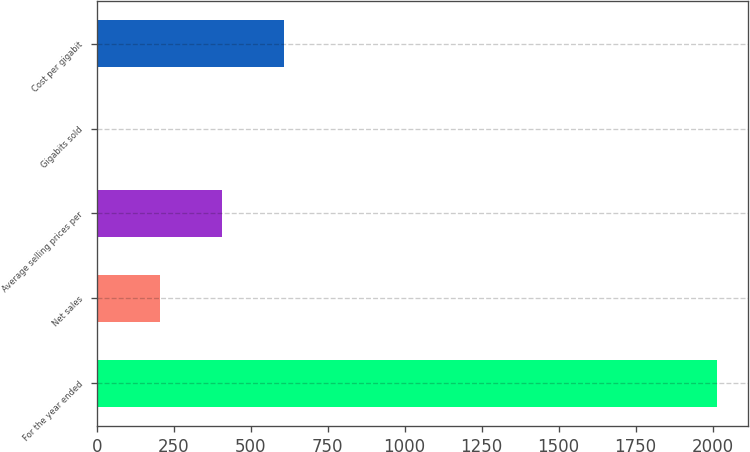Convert chart. <chart><loc_0><loc_0><loc_500><loc_500><bar_chart><fcel>For the year ended<fcel>Net sales<fcel>Average selling prices per<fcel>Gigabits sold<fcel>Cost per gigabit<nl><fcel>2015<fcel>205.1<fcel>406.2<fcel>4<fcel>607.3<nl></chart> 